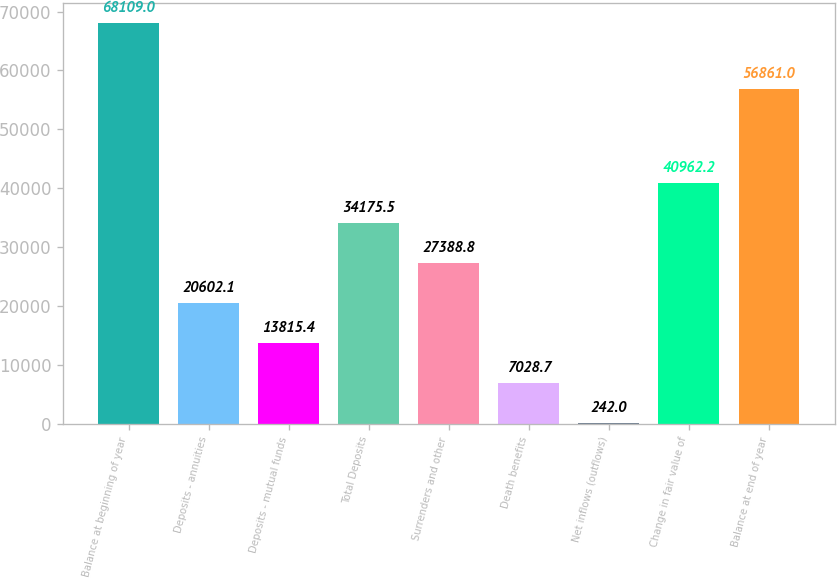Convert chart to OTSL. <chart><loc_0><loc_0><loc_500><loc_500><bar_chart><fcel>Balance at beginning of year<fcel>Deposits - annuities<fcel>Deposits - mutual funds<fcel>Total Deposits<fcel>Surrenders and other<fcel>Death benefits<fcel>Net inflows (outflows)<fcel>Change in fair value of<fcel>Balance at end of year<nl><fcel>68109<fcel>20602.1<fcel>13815.4<fcel>34175.5<fcel>27388.8<fcel>7028.7<fcel>242<fcel>40962.2<fcel>56861<nl></chart> 